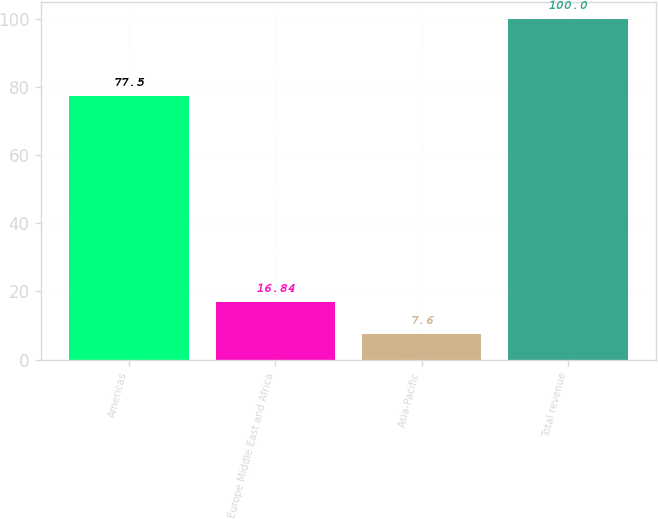Convert chart. <chart><loc_0><loc_0><loc_500><loc_500><bar_chart><fcel>Americas<fcel>Europe Middle East and Africa<fcel>Asia-Pacific<fcel>Total revenue<nl><fcel>77.5<fcel>16.84<fcel>7.6<fcel>100<nl></chart> 